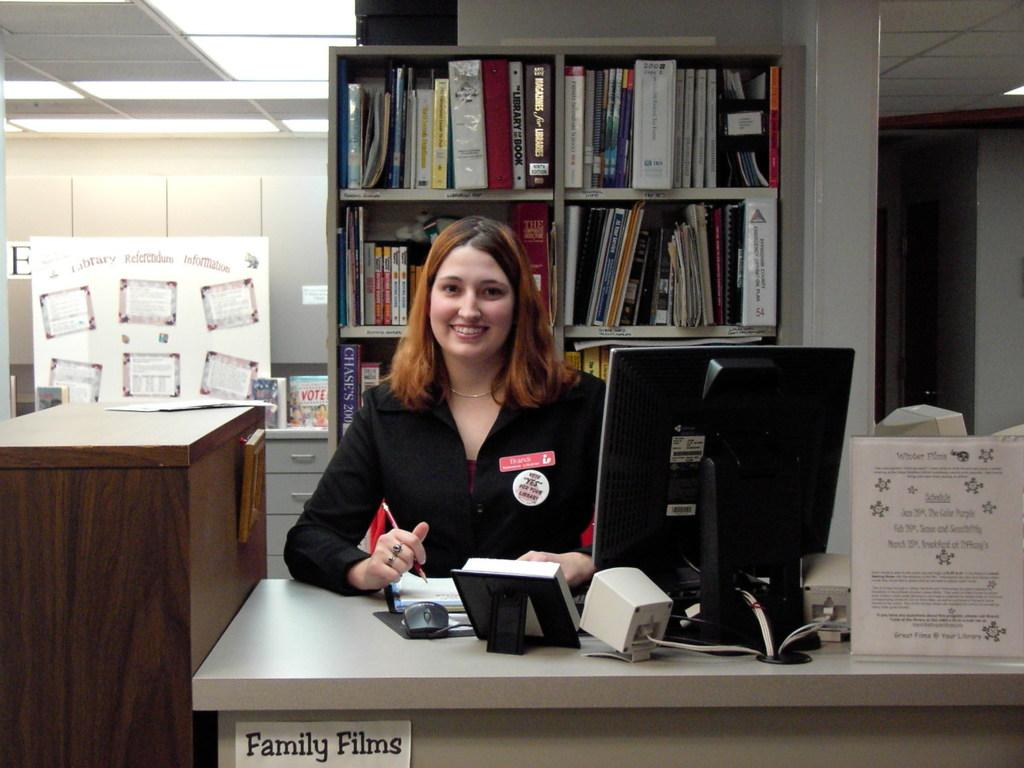<image>
Create a compact narrative representing the image presented. Brandi works in the family film section and appears happy about it. 